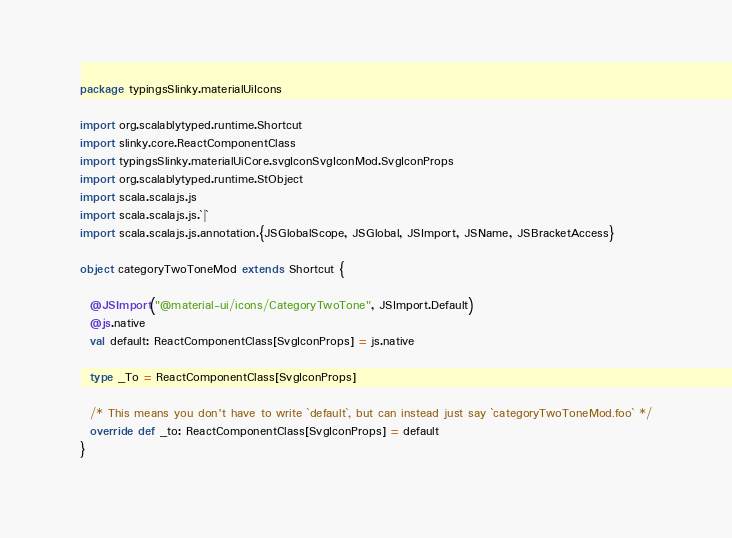<code> <loc_0><loc_0><loc_500><loc_500><_Scala_>package typingsSlinky.materialUiIcons

import org.scalablytyped.runtime.Shortcut
import slinky.core.ReactComponentClass
import typingsSlinky.materialUiCore.svgIconSvgIconMod.SvgIconProps
import org.scalablytyped.runtime.StObject
import scala.scalajs.js
import scala.scalajs.js.`|`
import scala.scalajs.js.annotation.{JSGlobalScope, JSGlobal, JSImport, JSName, JSBracketAccess}

object categoryTwoToneMod extends Shortcut {
  
  @JSImport("@material-ui/icons/CategoryTwoTone", JSImport.Default)
  @js.native
  val default: ReactComponentClass[SvgIconProps] = js.native
  
  type _To = ReactComponentClass[SvgIconProps]
  
  /* This means you don't have to write `default`, but can instead just say `categoryTwoToneMod.foo` */
  override def _to: ReactComponentClass[SvgIconProps] = default
}
</code> 